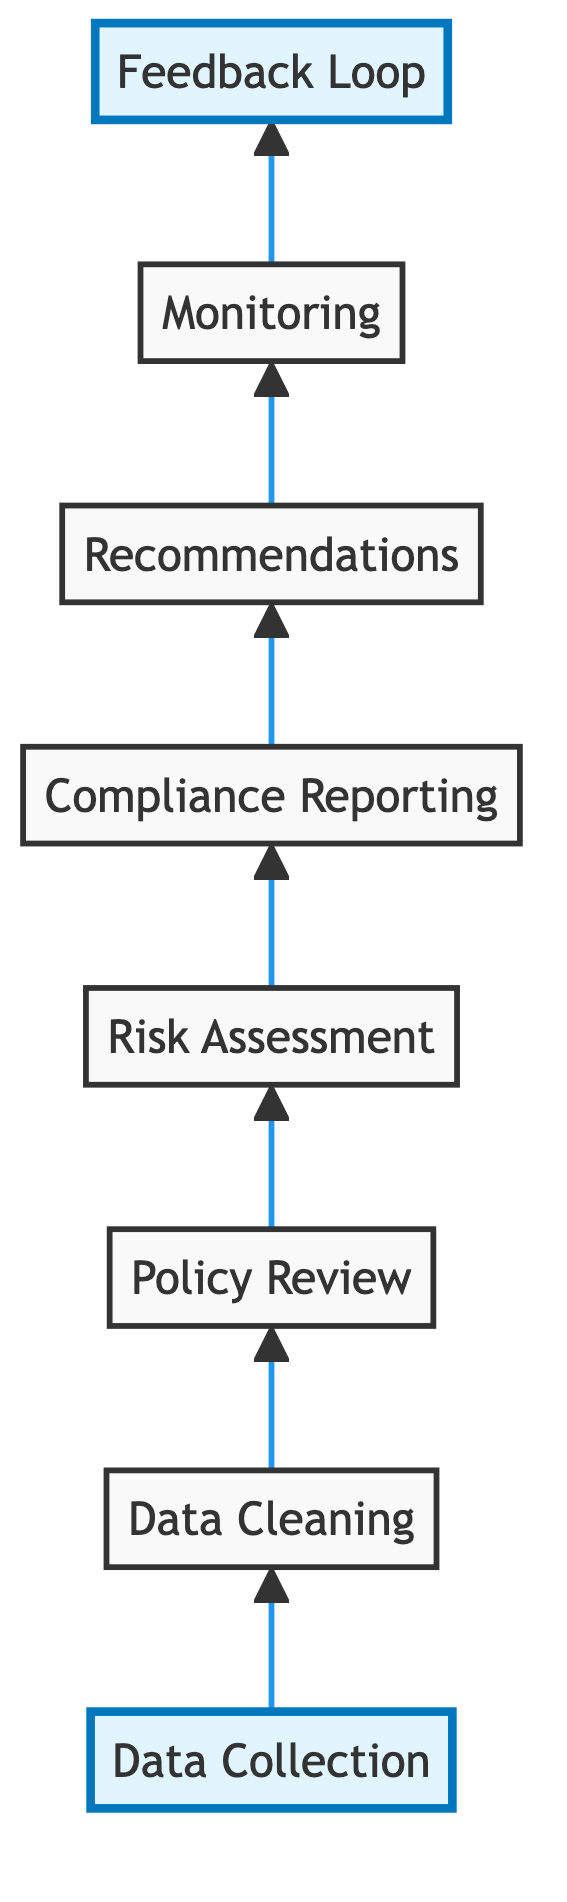What is the first step in the evaluation process? The first step in the diagram is "Data Collection," which is illustrated as the bottom node. It signifies the initial phase where various data is gathered.
Answer: Data Collection How many total steps are there in this flow chart? By counting the nodes in the diagram, we find there are a total of eight steps represented from "Data Collection" to "Feedback Loop."
Answer: Eight What is the last step in the evaluation process? The last step in the diagram is "Feedback Loop," which is depicted at the top of the chart, indicating it is the final phase of the evaluation process.
Answer: Feedback Loop Which step follows "Compliance Reporting"? According to the flow in the diagram, "Recommendations" directly follows "Compliance Reporting," indicating the next action taken after reporting compliance status.
Answer: Recommendations What type of system is implemented after the "Recommendations" step? The next step following "Recommendations" is "Monitoring," which implies that systems are set up to ensure that adherence to policies is observed after recommendations are made.
Answer: Monitoring Which two steps are interconnected and involve ensuring data accuracy? The steps "Data Collection" and "Data Cleaning" are interconnected, as "Data Cleaning" directly follows "Data Collection" and focuses on ensuring the accuracy of the data initially gathered.
Answer: Data Collection and Data Cleaning What is the purpose of the "Risk Assessment" step in this process? The "Risk Assessment" step evaluates the potential risks associated with the identified non-compliance issues that were compared against the policies. It utilizes the prior steps to inform its evaluation.
Answer: Evaluate potential risks How does "Feedback Loop" relate to the overall compliance process in the diagram? The "Feedback Loop" step relates to the overall compliance process by creating mechanisms for continuous improvement, which is aimed at refining compliance processes based on previous evaluations and monitoring results.
Answer: Continuous improvement mechanism What step directly contributes to accurate data processing? "Data Cleaning" is the step that directly contributes to accurate data processing by refining the data collected in the first step to ensure it is accurate and consistent for further analysis.
Answer: Data Cleaning 